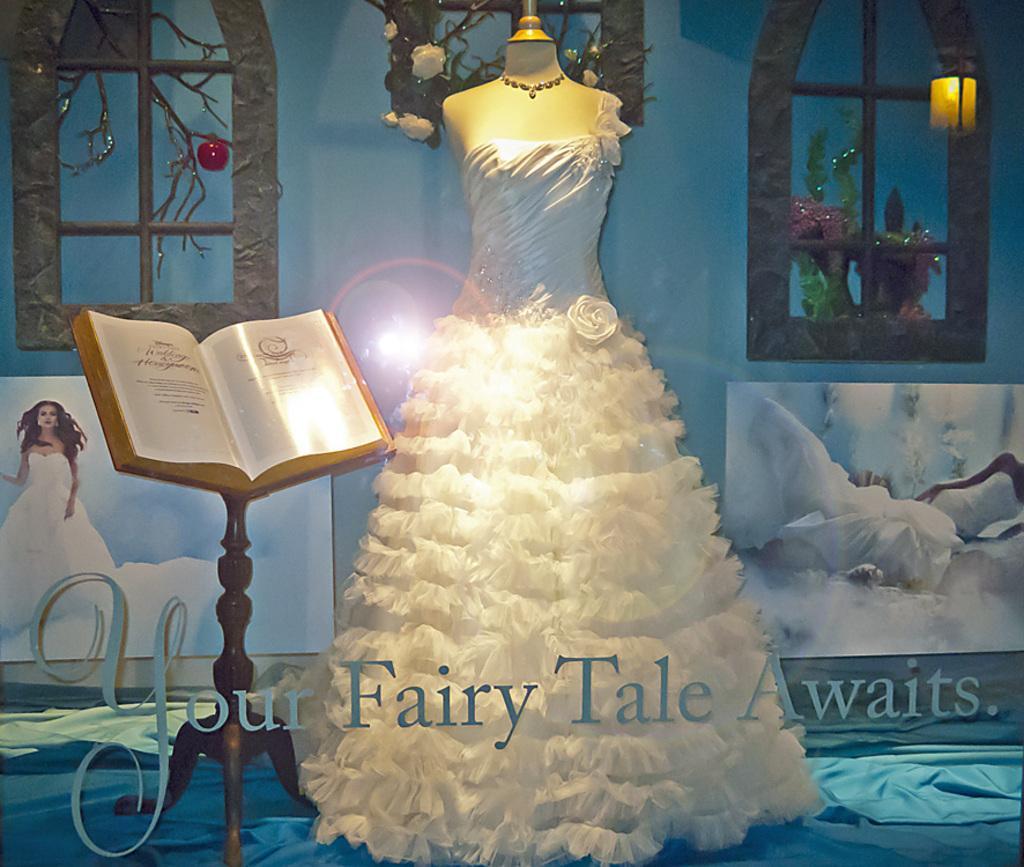Please provide a concise description of this image. In this picture there is a mannequin wearing gown, beside that there is a stand with book in it. 